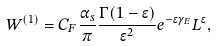Convert formula to latex. <formula><loc_0><loc_0><loc_500><loc_500>W ^ { ( 1 ) } = C _ { F } \frac { \alpha _ { s } } { \pi } \frac { \Gamma ( 1 - \epsilon ) } { \epsilon ^ { 2 } } e ^ { - \epsilon \gamma _ { E } } L ^ { \epsilon } ,</formula> 